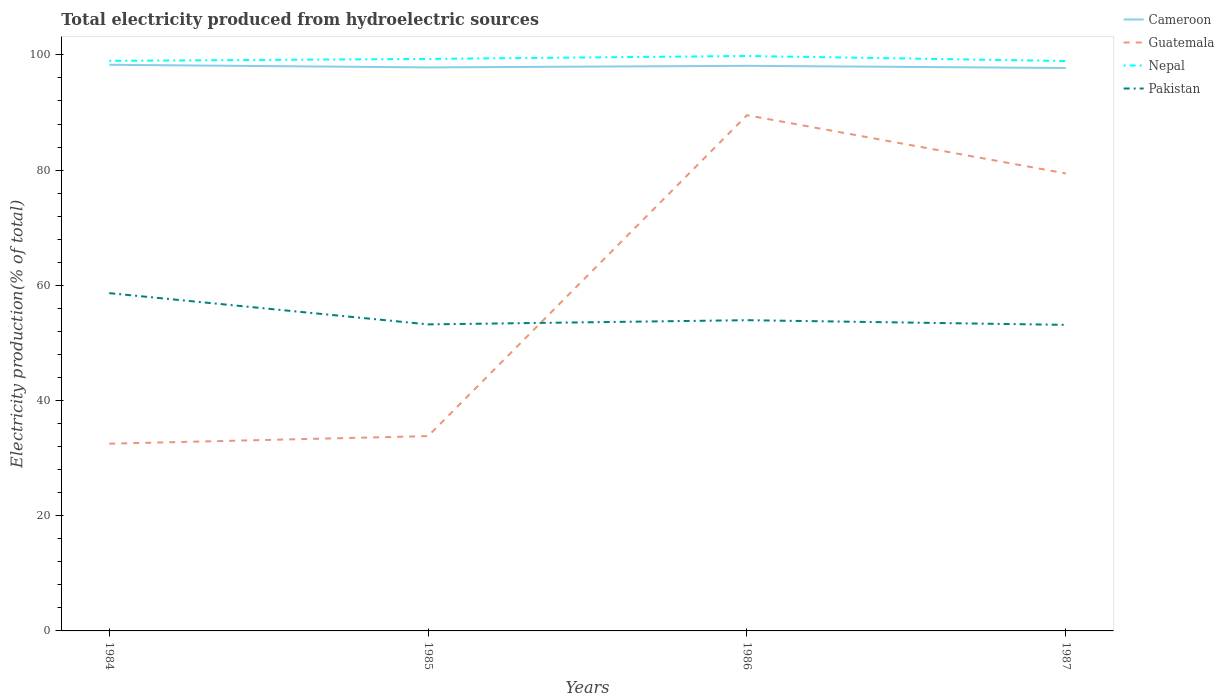Across all years, what is the maximum total electricity produced in Guatemala?
Ensure brevity in your answer.  32.5. What is the total total electricity produced in Guatemala in the graph?
Make the answer very short. -57.02. What is the difference between the highest and the second highest total electricity produced in Nepal?
Make the answer very short. 0.88. How many lines are there?
Offer a very short reply. 4. What is the difference between two consecutive major ticks on the Y-axis?
Your response must be concise. 20. Does the graph contain grids?
Keep it short and to the point. No. Where does the legend appear in the graph?
Provide a succinct answer. Top right. How are the legend labels stacked?
Keep it short and to the point. Vertical. What is the title of the graph?
Offer a very short reply. Total electricity produced from hydroelectric sources. What is the Electricity production(% of total) in Cameroon in 1984?
Make the answer very short. 98.29. What is the Electricity production(% of total) of Guatemala in 1984?
Provide a succinct answer. 32.5. What is the Electricity production(% of total) in Nepal in 1984?
Keep it short and to the point. 98.96. What is the Electricity production(% of total) of Pakistan in 1984?
Your response must be concise. 58.64. What is the Electricity production(% of total) of Cameroon in 1985?
Make the answer very short. 97.83. What is the Electricity production(% of total) of Guatemala in 1985?
Your response must be concise. 33.82. What is the Electricity production(% of total) of Nepal in 1985?
Give a very brief answer. 99.3. What is the Electricity production(% of total) in Pakistan in 1985?
Keep it short and to the point. 53.21. What is the Electricity production(% of total) of Cameroon in 1986?
Offer a terse response. 98.1. What is the Electricity production(% of total) of Guatemala in 1986?
Your response must be concise. 89.53. What is the Electricity production(% of total) of Nepal in 1986?
Offer a terse response. 99.82. What is the Electricity production(% of total) of Pakistan in 1986?
Offer a terse response. 53.95. What is the Electricity production(% of total) in Cameroon in 1987?
Ensure brevity in your answer.  97.73. What is the Electricity production(% of total) of Guatemala in 1987?
Provide a short and direct response. 79.42. What is the Electricity production(% of total) in Nepal in 1987?
Keep it short and to the point. 98.94. What is the Electricity production(% of total) in Pakistan in 1987?
Provide a succinct answer. 53.13. Across all years, what is the maximum Electricity production(% of total) in Cameroon?
Your answer should be compact. 98.29. Across all years, what is the maximum Electricity production(% of total) in Guatemala?
Make the answer very short. 89.53. Across all years, what is the maximum Electricity production(% of total) in Nepal?
Provide a short and direct response. 99.82. Across all years, what is the maximum Electricity production(% of total) in Pakistan?
Offer a very short reply. 58.64. Across all years, what is the minimum Electricity production(% of total) in Cameroon?
Ensure brevity in your answer.  97.73. Across all years, what is the minimum Electricity production(% of total) of Guatemala?
Offer a very short reply. 32.5. Across all years, what is the minimum Electricity production(% of total) in Nepal?
Provide a short and direct response. 98.94. Across all years, what is the minimum Electricity production(% of total) of Pakistan?
Your answer should be very brief. 53.13. What is the total Electricity production(% of total) of Cameroon in the graph?
Offer a terse response. 391.94. What is the total Electricity production(% of total) of Guatemala in the graph?
Your response must be concise. 235.27. What is the total Electricity production(% of total) in Nepal in the graph?
Your response must be concise. 397.02. What is the total Electricity production(% of total) in Pakistan in the graph?
Make the answer very short. 218.93. What is the difference between the Electricity production(% of total) of Cameroon in 1984 and that in 1985?
Make the answer very short. 0.46. What is the difference between the Electricity production(% of total) in Guatemala in 1984 and that in 1985?
Your answer should be very brief. -1.32. What is the difference between the Electricity production(% of total) in Nepal in 1984 and that in 1985?
Provide a short and direct response. -0.34. What is the difference between the Electricity production(% of total) in Pakistan in 1984 and that in 1985?
Provide a short and direct response. 5.42. What is the difference between the Electricity production(% of total) of Cameroon in 1984 and that in 1986?
Give a very brief answer. 0.18. What is the difference between the Electricity production(% of total) in Guatemala in 1984 and that in 1986?
Offer a very short reply. -57.02. What is the difference between the Electricity production(% of total) in Nepal in 1984 and that in 1986?
Ensure brevity in your answer.  -0.85. What is the difference between the Electricity production(% of total) in Pakistan in 1984 and that in 1986?
Keep it short and to the point. 4.69. What is the difference between the Electricity production(% of total) of Cameroon in 1984 and that in 1987?
Your answer should be very brief. 0.56. What is the difference between the Electricity production(% of total) in Guatemala in 1984 and that in 1987?
Your answer should be compact. -46.92. What is the difference between the Electricity production(% of total) in Nepal in 1984 and that in 1987?
Give a very brief answer. 0.03. What is the difference between the Electricity production(% of total) of Pakistan in 1984 and that in 1987?
Your response must be concise. 5.51. What is the difference between the Electricity production(% of total) in Cameroon in 1985 and that in 1986?
Provide a short and direct response. -0.27. What is the difference between the Electricity production(% of total) of Guatemala in 1985 and that in 1986?
Your response must be concise. -55.71. What is the difference between the Electricity production(% of total) in Nepal in 1985 and that in 1986?
Keep it short and to the point. -0.51. What is the difference between the Electricity production(% of total) in Pakistan in 1985 and that in 1986?
Make the answer very short. -0.73. What is the difference between the Electricity production(% of total) of Cameroon in 1985 and that in 1987?
Make the answer very short. 0.1. What is the difference between the Electricity production(% of total) in Guatemala in 1985 and that in 1987?
Keep it short and to the point. -45.6. What is the difference between the Electricity production(% of total) in Nepal in 1985 and that in 1987?
Your response must be concise. 0.37. What is the difference between the Electricity production(% of total) in Pakistan in 1985 and that in 1987?
Your response must be concise. 0.08. What is the difference between the Electricity production(% of total) of Cameroon in 1986 and that in 1987?
Make the answer very short. 0.38. What is the difference between the Electricity production(% of total) of Guatemala in 1986 and that in 1987?
Offer a very short reply. 10.11. What is the difference between the Electricity production(% of total) in Nepal in 1986 and that in 1987?
Your answer should be very brief. 0.88. What is the difference between the Electricity production(% of total) in Pakistan in 1986 and that in 1987?
Your answer should be very brief. 0.81. What is the difference between the Electricity production(% of total) of Cameroon in 1984 and the Electricity production(% of total) of Guatemala in 1985?
Make the answer very short. 64.46. What is the difference between the Electricity production(% of total) of Cameroon in 1984 and the Electricity production(% of total) of Nepal in 1985?
Provide a succinct answer. -1.02. What is the difference between the Electricity production(% of total) of Cameroon in 1984 and the Electricity production(% of total) of Pakistan in 1985?
Ensure brevity in your answer.  45.07. What is the difference between the Electricity production(% of total) in Guatemala in 1984 and the Electricity production(% of total) in Nepal in 1985?
Offer a terse response. -66.8. What is the difference between the Electricity production(% of total) of Guatemala in 1984 and the Electricity production(% of total) of Pakistan in 1985?
Ensure brevity in your answer.  -20.71. What is the difference between the Electricity production(% of total) of Nepal in 1984 and the Electricity production(% of total) of Pakistan in 1985?
Your response must be concise. 45.75. What is the difference between the Electricity production(% of total) of Cameroon in 1984 and the Electricity production(% of total) of Guatemala in 1986?
Give a very brief answer. 8.76. What is the difference between the Electricity production(% of total) of Cameroon in 1984 and the Electricity production(% of total) of Nepal in 1986?
Ensure brevity in your answer.  -1.53. What is the difference between the Electricity production(% of total) in Cameroon in 1984 and the Electricity production(% of total) in Pakistan in 1986?
Offer a terse response. 44.34. What is the difference between the Electricity production(% of total) of Guatemala in 1984 and the Electricity production(% of total) of Nepal in 1986?
Ensure brevity in your answer.  -67.31. What is the difference between the Electricity production(% of total) in Guatemala in 1984 and the Electricity production(% of total) in Pakistan in 1986?
Provide a succinct answer. -21.44. What is the difference between the Electricity production(% of total) of Nepal in 1984 and the Electricity production(% of total) of Pakistan in 1986?
Ensure brevity in your answer.  45.02. What is the difference between the Electricity production(% of total) in Cameroon in 1984 and the Electricity production(% of total) in Guatemala in 1987?
Ensure brevity in your answer.  18.86. What is the difference between the Electricity production(% of total) in Cameroon in 1984 and the Electricity production(% of total) in Nepal in 1987?
Your answer should be very brief. -0.65. What is the difference between the Electricity production(% of total) in Cameroon in 1984 and the Electricity production(% of total) in Pakistan in 1987?
Provide a succinct answer. 45.15. What is the difference between the Electricity production(% of total) of Guatemala in 1984 and the Electricity production(% of total) of Nepal in 1987?
Keep it short and to the point. -66.43. What is the difference between the Electricity production(% of total) in Guatemala in 1984 and the Electricity production(% of total) in Pakistan in 1987?
Provide a short and direct response. -20.63. What is the difference between the Electricity production(% of total) in Nepal in 1984 and the Electricity production(% of total) in Pakistan in 1987?
Keep it short and to the point. 45.83. What is the difference between the Electricity production(% of total) in Cameroon in 1985 and the Electricity production(% of total) in Guatemala in 1986?
Offer a very short reply. 8.3. What is the difference between the Electricity production(% of total) of Cameroon in 1985 and the Electricity production(% of total) of Nepal in 1986?
Keep it short and to the point. -1.99. What is the difference between the Electricity production(% of total) of Cameroon in 1985 and the Electricity production(% of total) of Pakistan in 1986?
Keep it short and to the point. 43.88. What is the difference between the Electricity production(% of total) in Guatemala in 1985 and the Electricity production(% of total) in Nepal in 1986?
Your answer should be very brief. -65.99. What is the difference between the Electricity production(% of total) in Guatemala in 1985 and the Electricity production(% of total) in Pakistan in 1986?
Keep it short and to the point. -20.12. What is the difference between the Electricity production(% of total) in Nepal in 1985 and the Electricity production(% of total) in Pakistan in 1986?
Offer a very short reply. 45.36. What is the difference between the Electricity production(% of total) of Cameroon in 1985 and the Electricity production(% of total) of Guatemala in 1987?
Your response must be concise. 18.41. What is the difference between the Electricity production(% of total) in Cameroon in 1985 and the Electricity production(% of total) in Nepal in 1987?
Your answer should be very brief. -1.11. What is the difference between the Electricity production(% of total) of Cameroon in 1985 and the Electricity production(% of total) of Pakistan in 1987?
Provide a succinct answer. 44.7. What is the difference between the Electricity production(% of total) in Guatemala in 1985 and the Electricity production(% of total) in Nepal in 1987?
Give a very brief answer. -65.11. What is the difference between the Electricity production(% of total) of Guatemala in 1985 and the Electricity production(% of total) of Pakistan in 1987?
Provide a succinct answer. -19.31. What is the difference between the Electricity production(% of total) of Nepal in 1985 and the Electricity production(% of total) of Pakistan in 1987?
Offer a very short reply. 46.17. What is the difference between the Electricity production(% of total) in Cameroon in 1986 and the Electricity production(% of total) in Guatemala in 1987?
Provide a succinct answer. 18.68. What is the difference between the Electricity production(% of total) in Cameroon in 1986 and the Electricity production(% of total) in Nepal in 1987?
Provide a short and direct response. -0.83. What is the difference between the Electricity production(% of total) in Cameroon in 1986 and the Electricity production(% of total) in Pakistan in 1987?
Keep it short and to the point. 44.97. What is the difference between the Electricity production(% of total) in Guatemala in 1986 and the Electricity production(% of total) in Nepal in 1987?
Keep it short and to the point. -9.41. What is the difference between the Electricity production(% of total) of Guatemala in 1986 and the Electricity production(% of total) of Pakistan in 1987?
Your answer should be very brief. 36.4. What is the difference between the Electricity production(% of total) in Nepal in 1986 and the Electricity production(% of total) in Pakistan in 1987?
Offer a terse response. 46.68. What is the average Electricity production(% of total) of Cameroon per year?
Your answer should be very brief. 97.99. What is the average Electricity production(% of total) of Guatemala per year?
Offer a very short reply. 58.82. What is the average Electricity production(% of total) in Nepal per year?
Your answer should be very brief. 99.25. What is the average Electricity production(% of total) of Pakistan per year?
Make the answer very short. 54.73. In the year 1984, what is the difference between the Electricity production(% of total) of Cameroon and Electricity production(% of total) of Guatemala?
Keep it short and to the point. 65.78. In the year 1984, what is the difference between the Electricity production(% of total) of Cameroon and Electricity production(% of total) of Nepal?
Give a very brief answer. -0.68. In the year 1984, what is the difference between the Electricity production(% of total) of Cameroon and Electricity production(% of total) of Pakistan?
Provide a succinct answer. 39.65. In the year 1984, what is the difference between the Electricity production(% of total) in Guatemala and Electricity production(% of total) in Nepal?
Offer a terse response. -66.46. In the year 1984, what is the difference between the Electricity production(% of total) of Guatemala and Electricity production(% of total) of Pakistan?
Provide a short and direct response. -26.14. In the year 1984, what is the difference between the Electricity production(% of total) of Nepal and Electricity production(% of total) of Pakistan?
Your answer should be very brief. 40.33. In the year 1985, what is the difference between the Electricity production(% of total) of Cameroon and Electricity production(% of total) of Guatemala?
Keep it short and to the point. 64.01. In the year 1985, what is the difference between the Electricity production(% of total) of Cameroon and Electricity production(% of total) of Nepal?
Ensure brevity in your answer.  -1.47. In the year 1985, what is the difference between the Electricity production(% of total) of Cameroon and Electricity production(% of total) of Pakistan?
Ensure brevity in your answer.  44.61. In the year 1985, what is the difference between the Electricity production(% of total) in Guatemala and Electricity production(% of total) in Nepal?
Provide a succinct answer. -65.48. In the year 1985, what is the difference between the Electricity production(% of total) of Guatemala and Electricity production(% of total) of Pakistan?
Your answer should be compact. -19.39. In the year 1985, what is the difference between the Electricity production(% of total) in Nepal and Electricity production(% of total) in Pakistan?
Ensure brevity in your answer.  46.09. In the year 1986, what is the difference between the Electricity production(% of total) in Cameroon and Electricity production(% of total) in Guatemala?
Your answer should be very brief. 8.58. In the year 1986, what is the difference between the Electricity production(% of total) of Cameroon and Electricity production(% of total) of Nepal?
Offer a terse response. -1.71. In the year 1986, what is the difference between the Electricity production(% of total) in Cameroon and Electricity production(% of total) in Pakistan?
Your answer should be compact. 44.16. In the year 1986, what is the difference between the Electricity production(% of total) of Guatemala and Electricity production(% of total) of Nepal?
Ensure brevity in your answer.  -10.29. In the year 1986, what is the difference between the Electricity production(% of total) in Guatemala and Electricity production(% of total) in Pakistan?
Offer a terse response. 35.58. In the year 1986, what is the difference between the Electricity production(% of total) of Nepal and Electricity production(% of total) of Pakistan?
Provide a short and direct response. 45.87. In the year 1987, what is the difference between the Electricity production(% of total) in Cameroon and Electricity production(% of total) in Guatemala?
Offer a very short reply. 18.31. In the year 1987, what is the difference between the Electricity production(% of total) in Cameroon and Electricity production(% of total) in Nepal?
Provide a succinct answer. -1.21. In the year 1987, what is the difference between the Electricity production(% of total) in Cameroon and Electricity production(% of total) in Pakistan?
Provide a succinct answer. 44.6. In the year 1987, what is the difference between the Electricity production(% of total) of Guatemala and Electricity production(% of total) of Nepal?
Offer a very short reply. -19.52. In the year 1987, what is the difference between the Electricity production(% of total) of Guatemala and Electricity production(% of total) of Pakistan?
Give a very brief answer. 26.29. In the year 1987, what is the difference between the Electricity production(% of total) of Nepal and Electricity production(% of total) of Pakistan?
Your answer should be very brief. 45.81. What is the ratio of the Electricity production(% of total) in Pakistan in 1984 to that in 1985?
Your response must be concise. 1.1. What is the ratio of the Electricity production(% of total) in Guatemala in 1984 to that in 1986?
Offer a very short reply. 0.36. What is the ratio of the Electricity production(% of total) in Nepal in 1984 to that in 1986?
Ensure brevity in your answer.  0.99. What is the ratio of the Electricity production(% of total) of Pakistan in 1984 to that in 1986?
Offer a terse response. 1.09. What is the ratio of the Electricity production(% of total) of Cameroon in 1984 to that in 1987?
Give a very brief answer. 1.01. What is the ratio of the Electricity production(% of total) of Guatemala in 1984 to that in 1987?
Provide a succinct answer. 0.41. What is the ratio of the Electricity production(% of total) in Nepal in 1984 to that in 1987?
Your answer should be very brief. 1. What is the ratio of the Electricity production(% of total) in Pakistan in 1984 to that in 1987?
Provide a short and direct response. 1.1. What is the ratio of the Electricity production(% of total) in Guatemala in 1985 to that in 1986?
Ensure brevity in your answer.  0.38. What is the ratio of the Electricity production(% of total) in Pakistan in 1985 to that in 1986?
Offer a very short reply. 0.99. What is the ratio of the Electricity production(% of total) of Cameroon in 1985 to that in 1987?
Your answer should be compact. 1. What is the ratio of the Electricity production(% of total) of Guatemala in 1985 to that in 1987?
Provide a succinct answer. 0.43. What is the ratio of the Electricity production(% of total) in Nepal in 1985 to that in 1987?
Your answer should be compact. 1. What is the ratio of the Electricity production(% of total) in Pakistan in 1985 to that in 1987?
Your response must be concise. 1. What is the ratio of the Electricity production(% of total) in Cameroon in 1986 to that in 1987?
Make the answer very short. 1. What is the ratio of the Electricity production(% of total) in Guatemala in 1986 to that in 1987?
Provide a succinct answer. 1.13. What is the ratio of the Electricity production(% of total) of Nepal in 1986 to that in 1987?
Offer a very short reply. 1.01. What is the ratio of the Electricity production(% of total) in Pakistan in 1986 to that in 1987?
Give a very brief answer. 1.02. What is the difference between the highest and the second highest Electricity production(% of total) of Cameroon?
Provide a short and direct response. 0.18. What is the difference between the highest and the second highest Electricity production(% of total) of Guatemala?
Give a very brief answer. 10.11. What is the difference between the highest and the second highest Electricity production(% of total) of Nepal?
Keep it short and to the point. 0.51. What is the difference between the highest and the second highest Electricity production(% of total) of Pakistan?
Provide a short and direct response. 4.69. What is the difference between the highest and the lowest Electricity production(% of total) in Cameroon?
Your answer should be very brief. 0.56. What is the difference between the highest and the lowest Electricity production(% of total) of Guatemala?
Your answer should be very brief. 57.02. What is the difference between the highest and the lowest Electricity production(% of total) of Nepal?
Your response must be concise. 0.88. What is the difference between the highest and the lowest Electricity production(% of total) of Pakistan?
Offer a terse response. 5.51. 